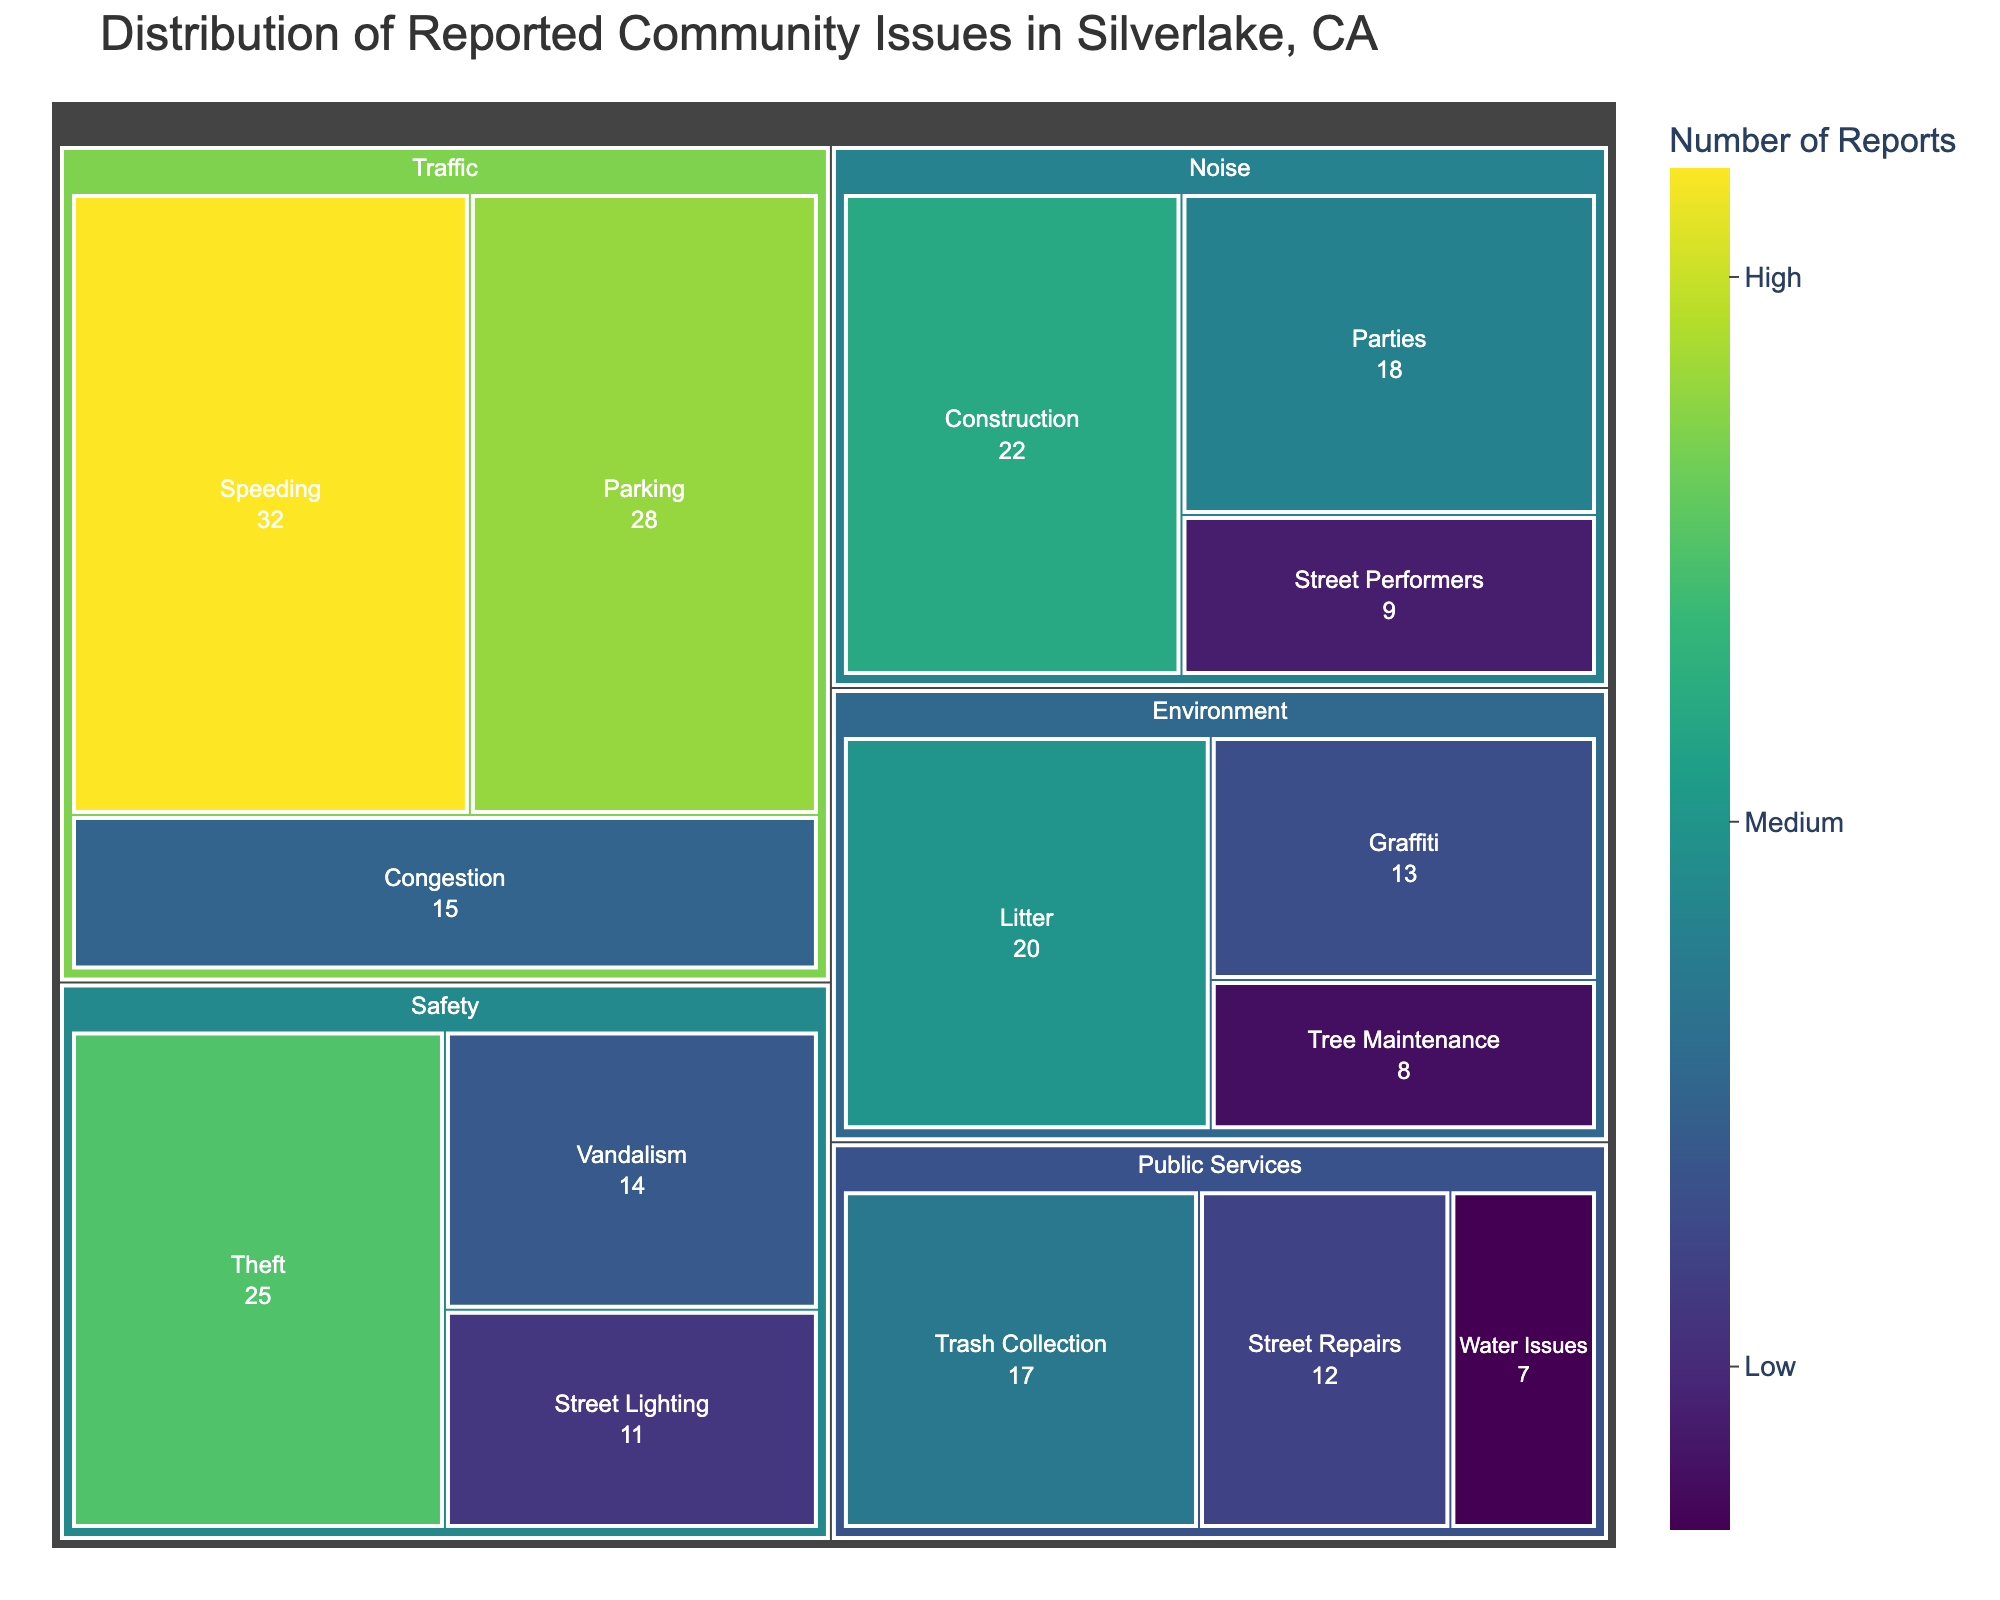What is the title of the treemap? The title can be found at the top of the figure, providing a brief description of what the treemap represents. According to the information provided, the title is "Distribution of Reported Community Issues in Silverlake, CA".
Answer: Distribution of Reported Community Issues in Silverlake, CA Which category has the highest number of reports in total? To find out which category has the highest number of reports, sum up the values of subcategories under each category. Traffic has 32 + 28 + 15 = 75, Noise has 22 + 18 + 9 = 49, Safety has 25 + 14 + 11 = 50, Environment has 20 + 13 + 8 = 41, and Public Services has 17 + 12 + 7 = 36. Traffic has the highest total reports of 75.
Answer: Traffic What are the subcategories under Noise and their values? Look for all the subcategories listed under Noise on the treemap. The values for each subcategory should be readily visible. They are Construction (22), Parties (18), and Street Performers (9).
Answer: Construction: 22, Parties: 18, Street Performers: 9 What is the combined number of reports for Noise and Environment categories? Sum the total reports for both Noise and Environment categories. Noise has a total of 22 + 18 + 9 = 49, and Environment has a total of 20 + 13 + 8 = 41. The combined total is 49 + 41 = 90.
Answer: 90 Which subcategory in the Traffic category has the lowest number of reports? Examine the subcategories under Traffic and compare their values. Speeding has 32, Parking has 28, and Congestion has 15. Congestion has the lowest number of reports with 15.
Answer: Congestion Which subcategory in the Safety category has the second highest number of reports? List the subcategories under Safety and their values: Theft (25), Vandalism (14), and Street Lighting (11). The second highest is Vandalism with 14 reports.
Answer: Vandalism How do the number of reports for Litter and Theft compare? Locate the values for Litter under Environment (20) and Theft under Safety (25). Compare the two values to see which one is higher. Theft has more reports (25) compared to Litter (20).
Answer: Theft has more reports What is the total number of reports for the subcategories under Public Services? Sum the values for all subcategories listed under Public Services. Trash Collection has 17, Street Repairs has 12, and Water Issues has 7. The total number of reports is 17 + 12 + 7 = 36.
Answer: 36 How does the number of Street Lighting reports compare to Tree Maintenance reports? Compare the values for Street Lighting under Safety (11) and Tree Maintenance under Environment (8). Street Lighting has more reports with 11 compared to Tree Maintenance with 8.
Answer: Street Lighting has more reports What is the average number of reports per subcategory for the Noise category? Firstly, sum the values of subcategories under Noise: Construction (22), Parties (18), and Street Performers (9). Total is 22 + 18 + 9 = 49. There are 3 subcategories, so the average is 49 / 3 = 16.33.
Answer: 16.33 